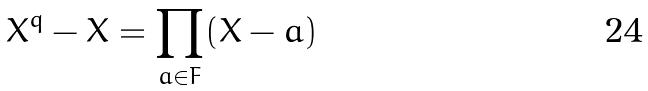<formula> <loc_0><loc_0><loc_500><loc_500>X ^ { q } - X = \prod _ { a \in F } ( X - a )</formula> 